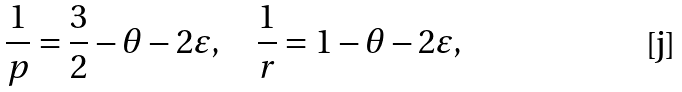Convert formula to latex. <formula><loc_0><loc_0><loc_500><loc_500>\frac { 1 } { p } = \frac { 3 } { 2 } - \theta - 2 \varepsilon , \quad \frac { 1 } { r } = 1 - \theta - 2 \varepsilon ,</formula> 